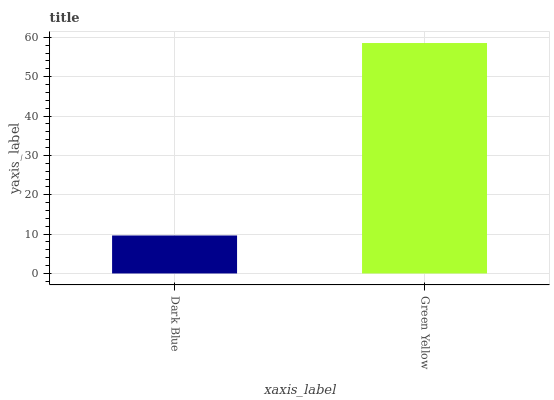Is Dark Blue the minimum?
Answer yes or no. Yes. Is Green Yellow the maximum?
Answer yes or no. Yes. Is Green Yellow the minimum?
Answer yes or no. No. Is Green Yellow greater than Dark Blue?
Answer yes or no. Yes. Is Dark Blue less than Green Yellow?
Answer yes or no. Yes. Is Dark Blue greater than Green Yellow?
Answer yes or no. No. Is Green Yellow less than Dark Blue?
Answer yes or no. No. Is Green Yellow the high median?
Answer yes or no. Yes. Is Dark Blue the low median?
Answer yes or no. Yes. Is Dark Blue the high median?
Answer yes or no. No. Is Green Yellow the low median?
Answer yes or no. No. 